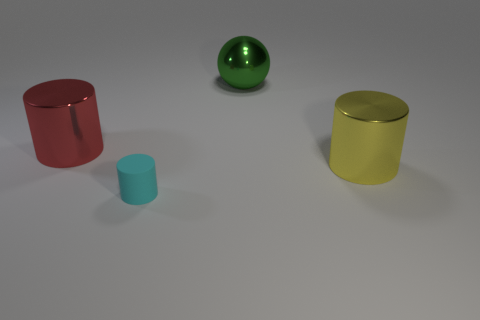Subtract all big metallic cylinders. How many cylinders are left? 1 Subtract 1 cylinders. How many cylinders are left? 2 Subtract all purple cylinders. Subtract all purple balls. How many cylinders are left? 3 Add 2 tiny cyan rubber objects. How many objects exist? 6 Subtract all spheres. How many objects are left? 3 Subtract all cylinders. Subtract all large green metal spheres. How many objects are left? 0 Add 1 big yellow cylinders. How many big yellow cylinders are left? 2 Add 3 big metal balls. How many big metal balls exist? 4 Subtract 0 cyan balls. How many objects are left? 4 